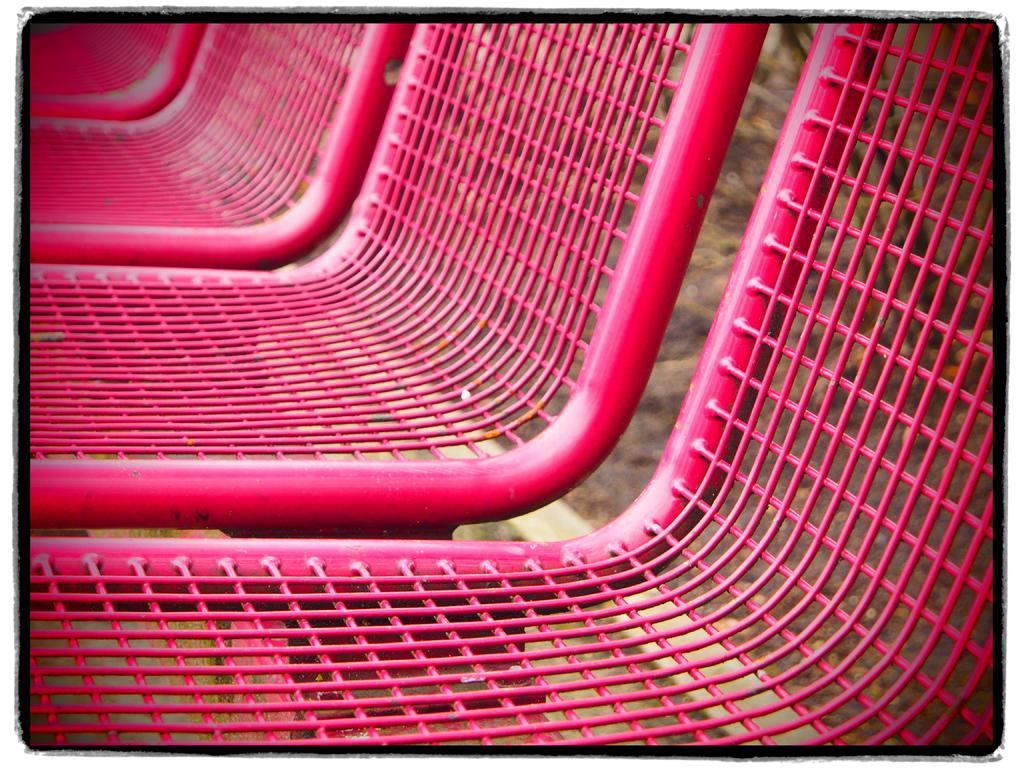Can you describe this image briefly? This image consists of chairs made up of metal. The chairs are in pink color. At the bottom, there is ground. 